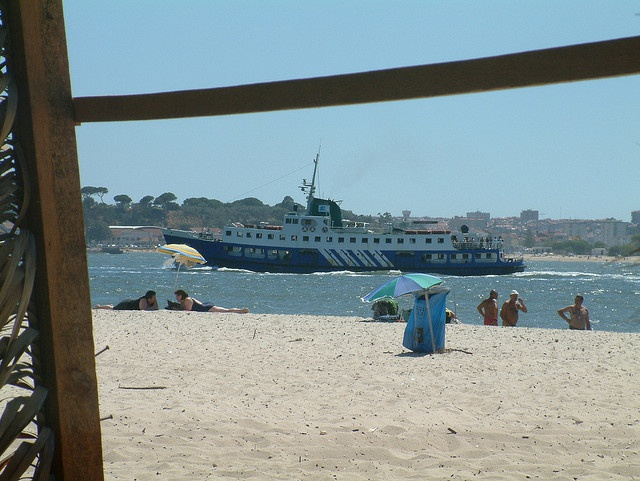Describe the objects in this image and their specific colors. I can see boat in black, navy, gray, and teal tones, umbrella in black, gray, darkgray, and teal tones, people in black and gray tones, people in black, gray, and darkgray tones, and umbrella in black, darkgray, tan, khaki, and lightgray tones in this image. 